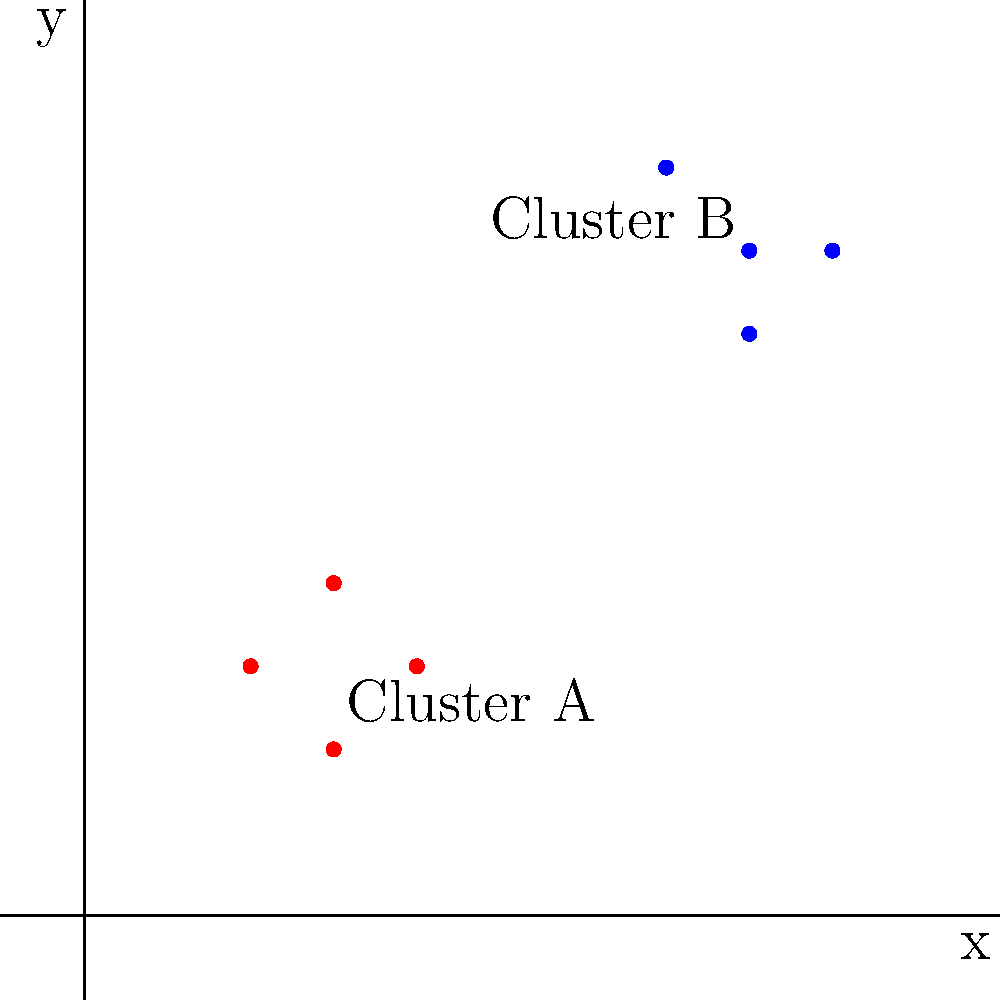In a resource allocation project, household locations are plotted on a 2D grid. Two clusters of needy households have been identified: Cluster A centered at (3,3) and Cluster B centered at (8,8). If a new household is located at (6,5), which cluster should it be assigned to for efficient resource distribution? To determine which cluster the new household should be assigned to, we need to calculate its distance from each cluster center and compare them. We'll use the distance formula between two points: $d = \sqrt{(x_2-x_1)^2 + (y_2-y_1)^2}$

Step 1: Calculate the distance from the new household (6,5) to Cluster A (3,3)
$d_A = \sqrt{(6-3)^2 + (5-3)^2} = \sqrt{3^2 + 2^2} = \sqrt{9 + 4} = \sqrt{13} \approx 3.61$

Step 2: Calculate the distance from the new household (6,5) to Cluster B (8,8)
$d_B = \sqrt{(6-8)^2 + (5-8)^2} = \sqrt{(-2)^2 + (-3)^2} = \sqrt{4 + 9} = \sqrt{13} \approx 3.61$

Step 3: Compare the distances
Both distances are equal (approximately 3.61 units).

Step 4: Make a decision
Since the distances are equal, we need to consider other factors. In this case, it's best to assign the new household to the cluster with fewer members to balance resource distribution. Cluster A has 4 households, while Cluster B has 4 households as well.

Given that both clusters have the same number of households and are equidistant from the new household, we can choose either cluster. However, for consistency, we'll assign it to Cluster A.
Answer: Cluster A 